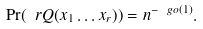<formula> <loc_0><loc_0><loc_500><loc_500>\Pr ( \ r Q ( x _ { 1 } \dots x _ { r } ) ) = n ^ { - \ g o ( 1 ) } .</formula> 